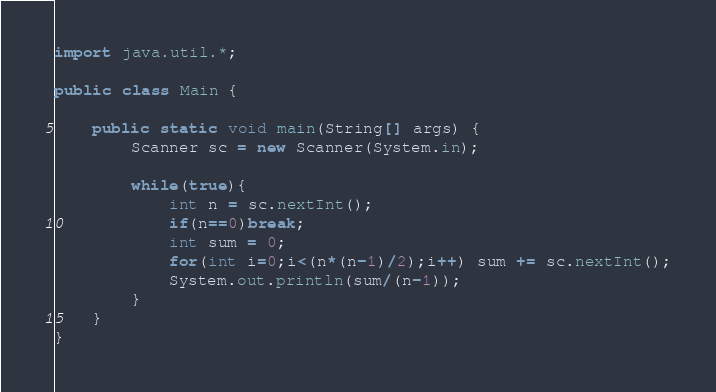Convert code to text. <code><loc_0><loc_0><loc_500><loc_500><_Java_>import java.util.*;

public class Main {
	
	public static void main(String[] args) {
		Scanner sc = new Scanner(System.in);
		
		while(true){
			int n = sc.nextInt();
			if(n==0)break;
			int sum = 0;
			for(int i=0;i<(n*(n-1)/2);i++) sum += sc.nextInt();
			System.out.println(sum/(n-1));
		}
	}	
}</code> 